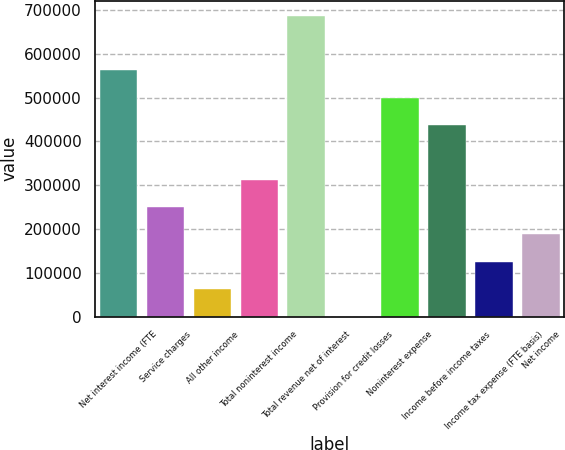Convert chart to OTSL. <chart><loc_0><loc_0><loc_500><loc_500><bar_chart><fcel>Net interest income (FTE<fcel>Service charges<fcel>All other income<fcel>Total noninterest income<fcel>Total revenue net of interest<fcel>Provision for credit losses<fcel>Noninterest expense<fcel>Income before income taxes<fcel>Income tax expense (FTE basis)<fcel>Net income<nl><fcel>562150<fcel>249941<fcel>62615.8<fcel>312383<fcel>687034<fcel>174<fcel>499708<fcel>437267<fcel>125058<fcel>187499<nl></chart> 